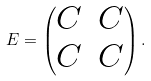Convert formula to latex. <formula><loc_0><loc_0><loc_500><loc_500>E = \begin{pmatrix} C & C \\ C & C \end{pmatrix} .</formula> 